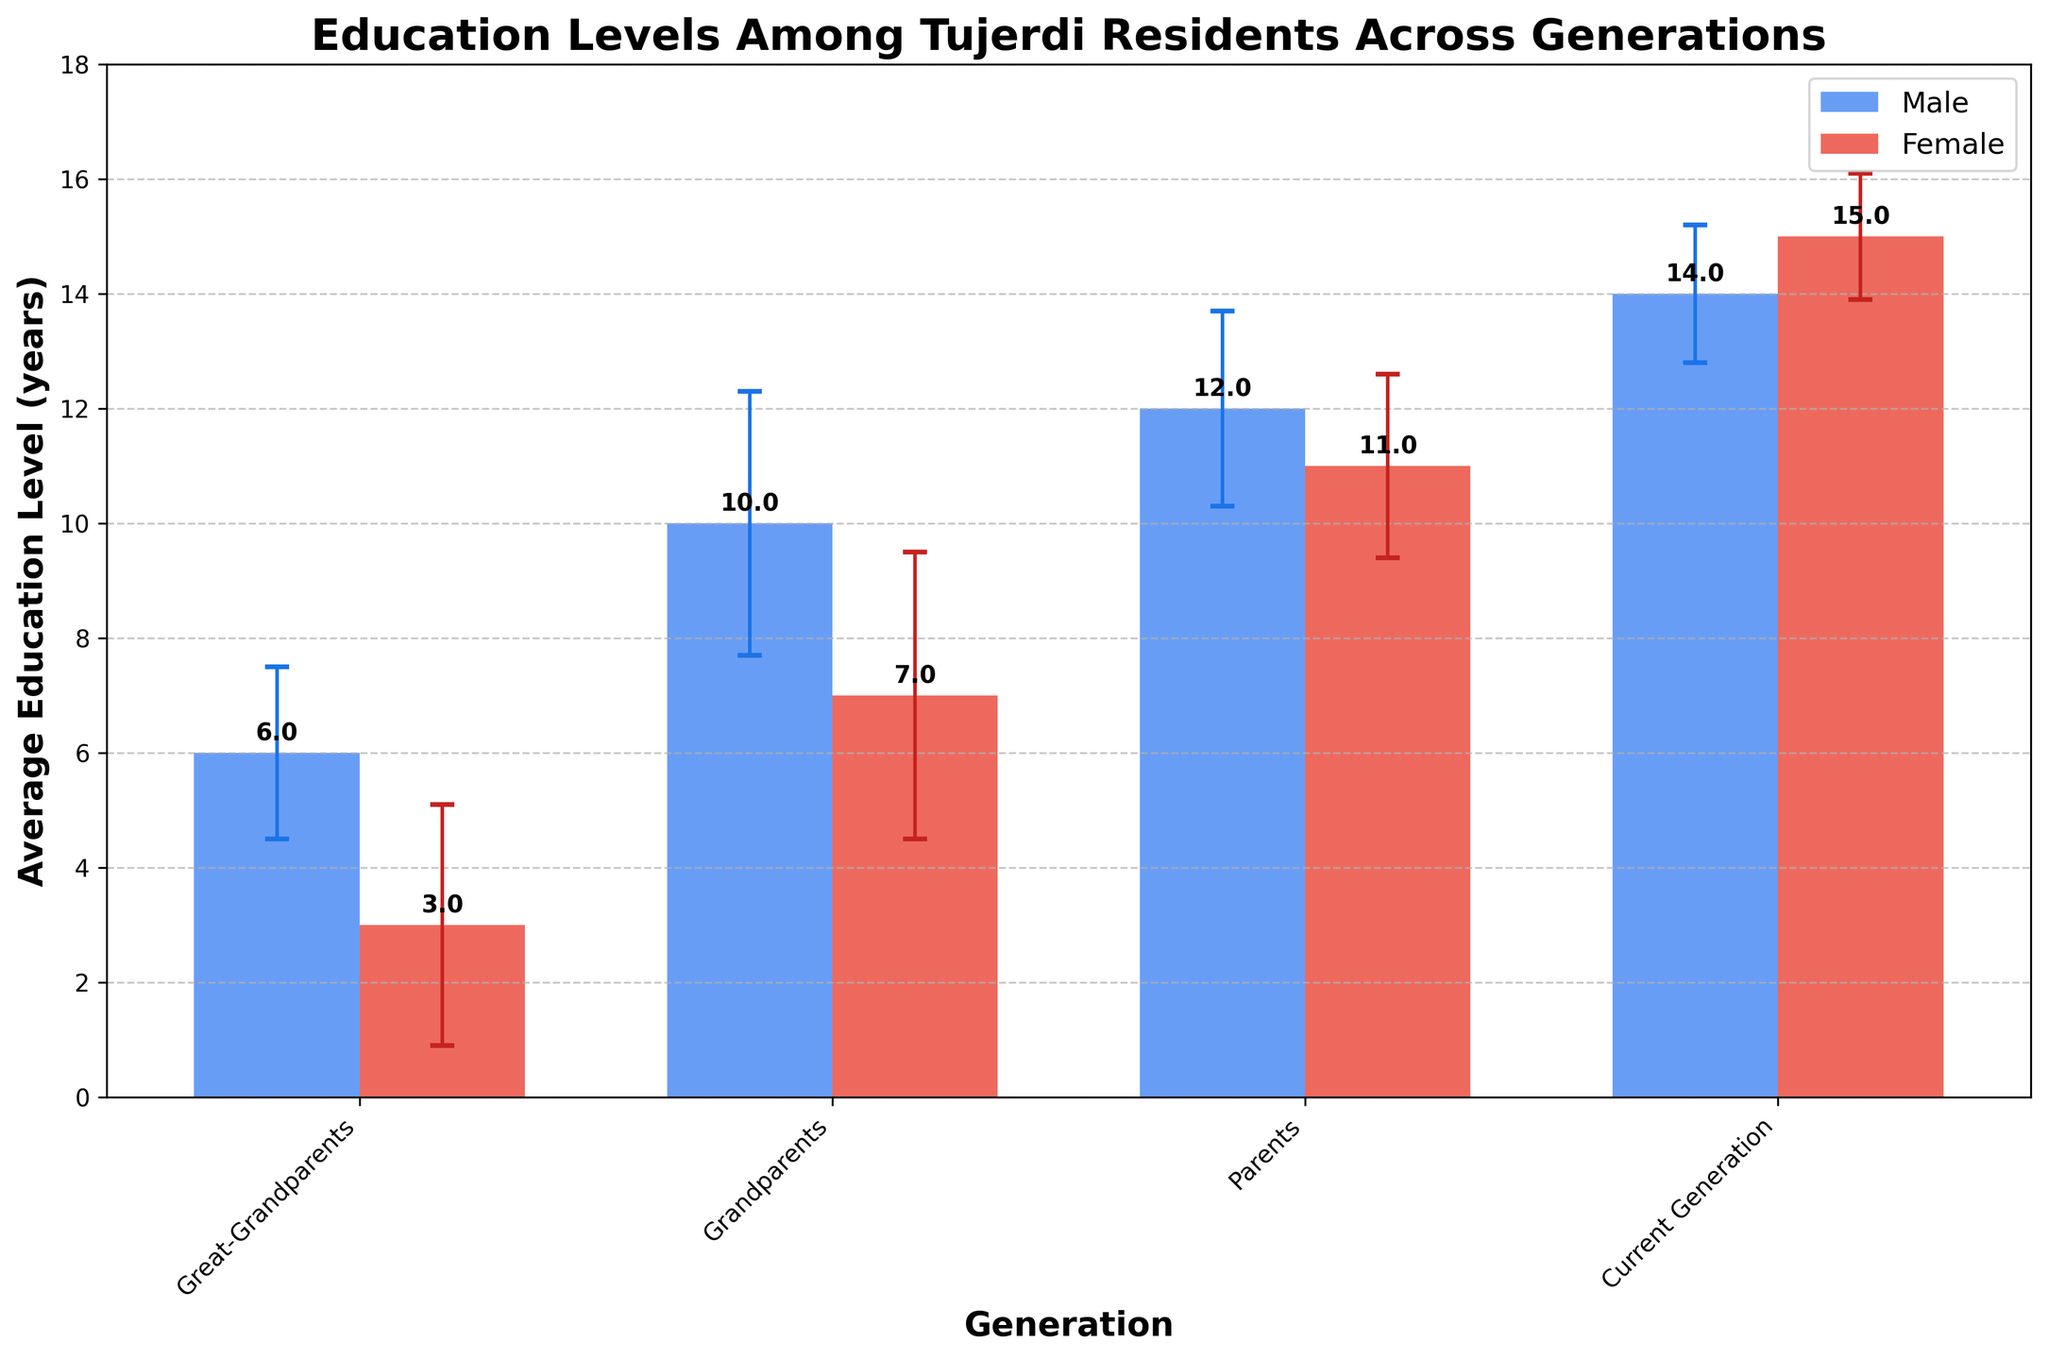How many generations are represented in the figure? The x-axis of the plot lists the different generations which can be counted. These include Great-Grandparents, Grandparents, Parents, and Current Generation.
Answer: 4 What is the average education level of males in the Current Generation? Look at the height of the bar corresponding to males in the Current Generation on the x-axis. The height of the bar is labeled and it shows the value.
Answer: 14 years Is there any generation where females have a higher average education level than males? Compare the heights of the bars for males and females in each generation. The only generation where the female bar is higher than the male bar is the Current Generation.
Answer: Yes, Current Generation What is the difference between the average education levels of males and females in the Grandparents' generation? Look at the bars for the Grandparents' generation. The male bar is at 10 years, and the female bar is at 7 years. Subtract 7 from 10 to get the difference.
Answer: 3 years Which gender has a larger standard deviation in education level among Great-Grandparents? The error bars indicate the standard deviation. The female error bar is visibly longer than the male error bar.
Answer: Female What is the average education level of females across all generations? Sum the average education levels of females in all generations: 3 (Great-Grandparents) + 7 (Grandparents) + 11 (Parents) + 15 (Current Generation). Then divide this sum by the number of generations, which is 4.
Answer: (3+7+11+15)/4 = 36/4 = 9 years Between which two consecutive generations did males experience the largest increase in average education level? Calculate the differences between consecutive generations for males: From Great-Grandparents to Grandparents (10-6=4), Grandparents to Parents (12-10=2), and Parents to Current Generation (14-12=2). The largest increase is from Great-Grandparents to Grandparents.
Answer: Great-Grandparents to Grandparents What is the ratio of the average education level of females to males in the Great-Grandparents' generation? The average education level for females is 3 years and for males is 6 years. Calculate the ratio 3/6.
Answer: 0.5 What does the y-axis represent in the figure? Observing the label on the y-axis which indicates the measured quantity, it represents the average education level measured in years.
Answer: Average Education Level (years) 